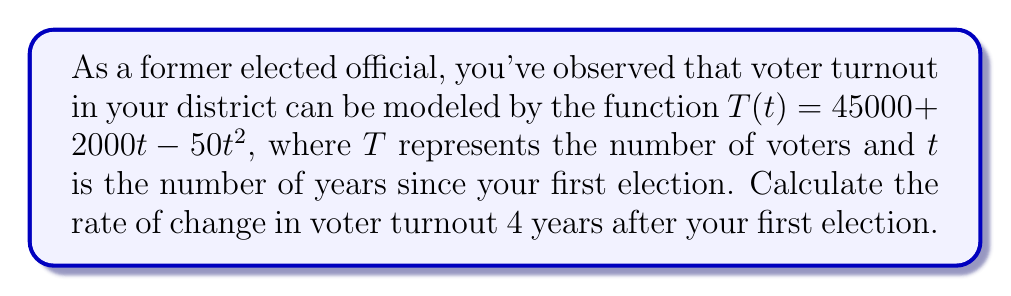Provide a solution to this math problem. To find the rate of change in voter turnout, we need to calculate the derivative of the given function and evaluate it at $t = 4$.

1) The given function is $T(t) = 45000 + 2000t - 50t^2$

2) To find the derivative, we apply the power rule:
   $\frac{d}{dt}(45000) = 0$
   $\frac{d}{dt}(2000t) = 2000$
   $\frac{d}{dt}(-50t^2) = -100t$

3) Combining these terms, we get the derivative:
   $T'(t) = 2000 - 100t$

4) Now, we evaluate $T'(4)$:
   $T'(4) = 2000 - 100(4)$
   $T'(4) = 2000 - 400$
   $T'(4) = 1600$

The rate of change at $t = 4$ is 1600 voters per year.
Answer: 1600 voters/year 